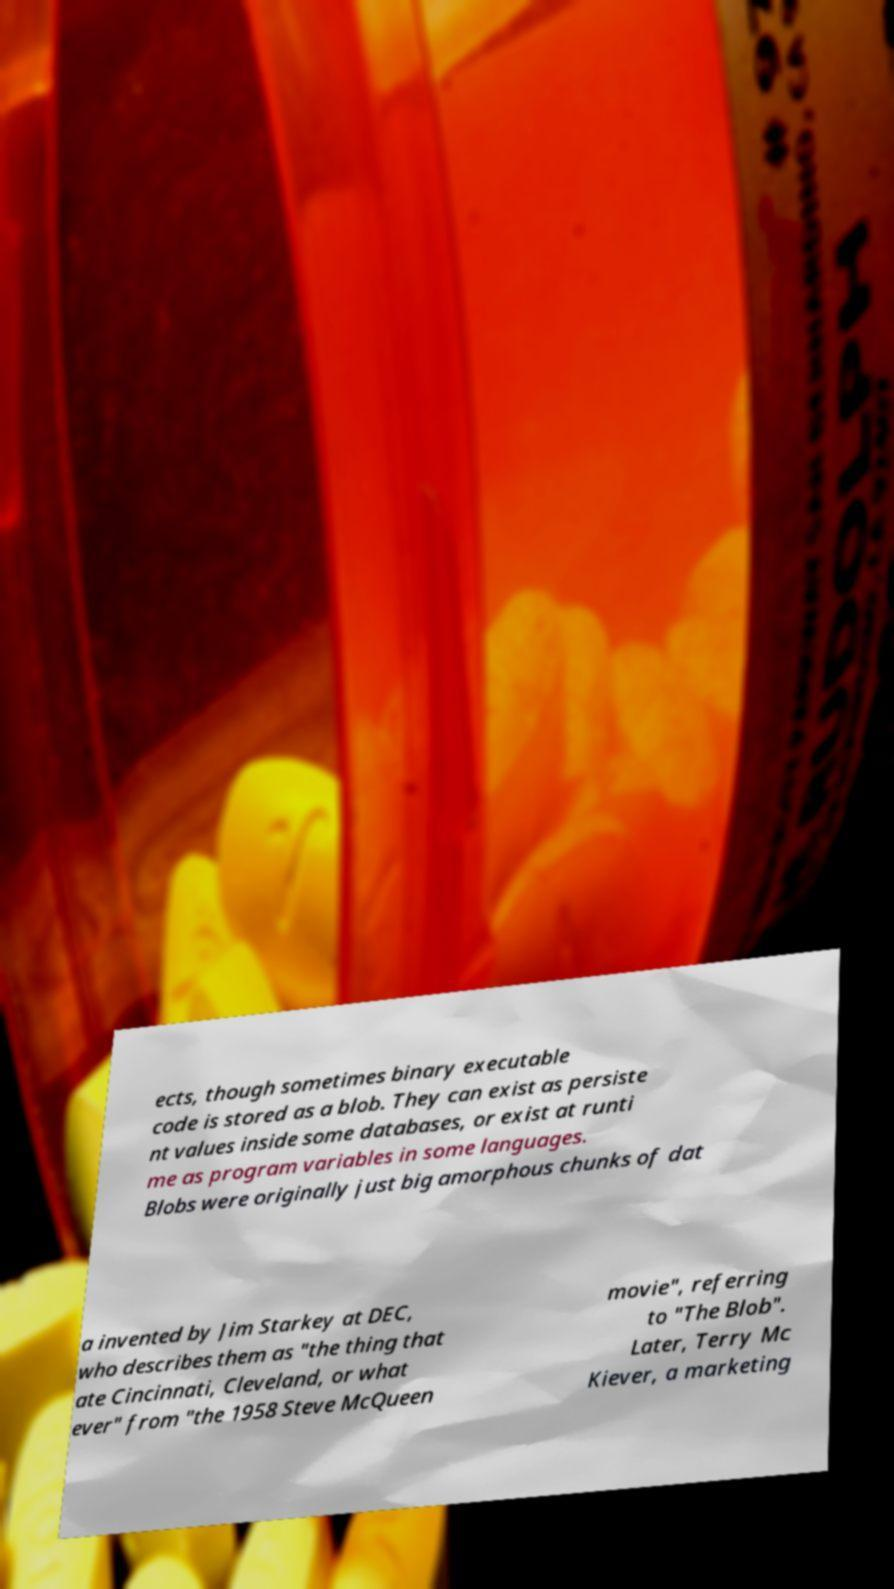I need the written content from this picture converted into text. Can you do that? ects, though sometimes binary executable code is stored as a blob. They can exist as persiste nt values inside some databases, or exist at runti me as program variables in some languages. Blobs were originally just big amorphous chunks of dat a invented by Jim Starkey at DEC, who describes them as "the thing that ate Cincinnati, Cleveland, or what ever" from "the 1958 Steve McQueen movie", referring to "The Blob". Later, Terry Mc Kiever, a marketing 